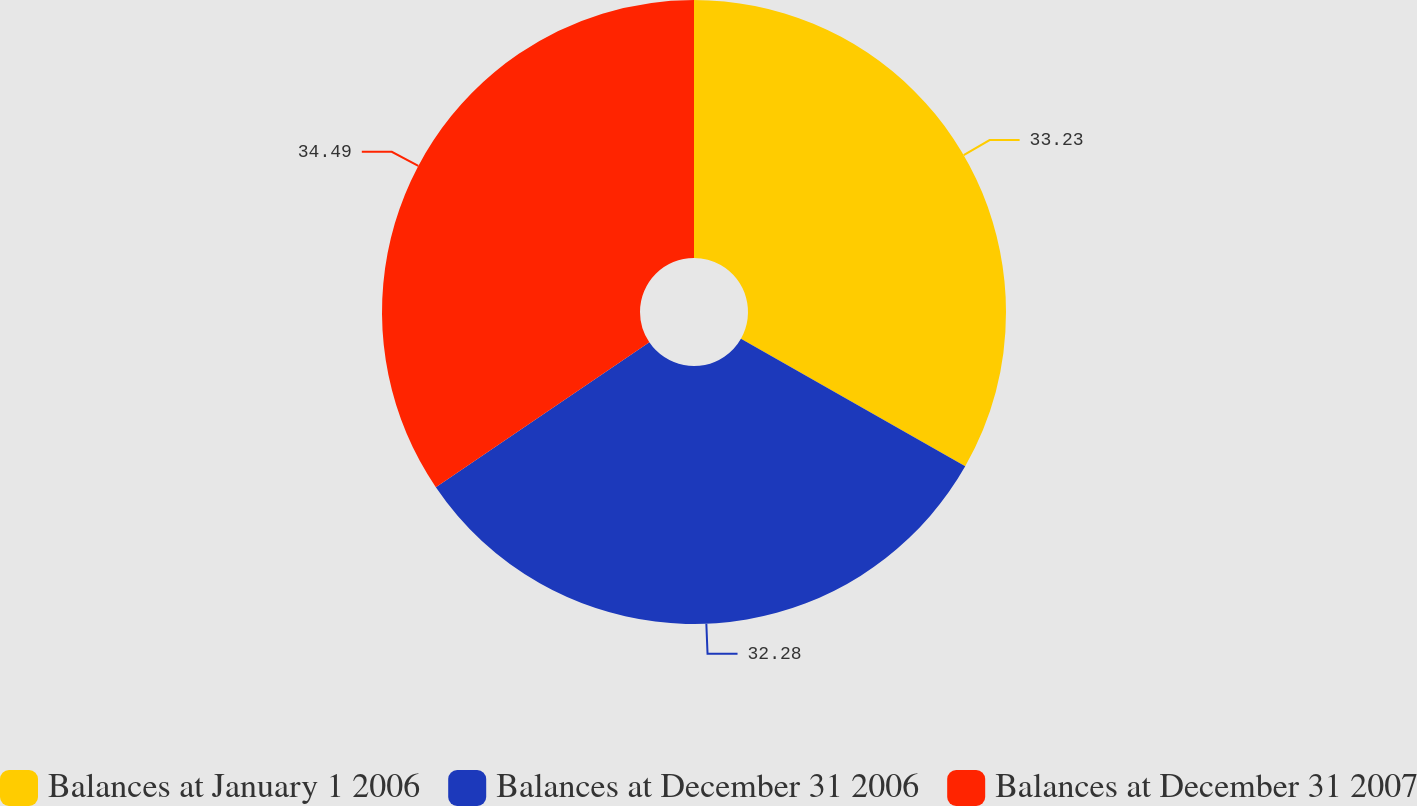Convert chart. <chart><loc_0><loc_0><loc_500><loc_500><pie_chart><fcel>Balances at January 1 2006<fcel>Balances at December 31 2006<fcel>Balances at December 31 2007<nl><fcel>33.23%<fcel>32.28%<fcel>34.49%<nl></chart> 